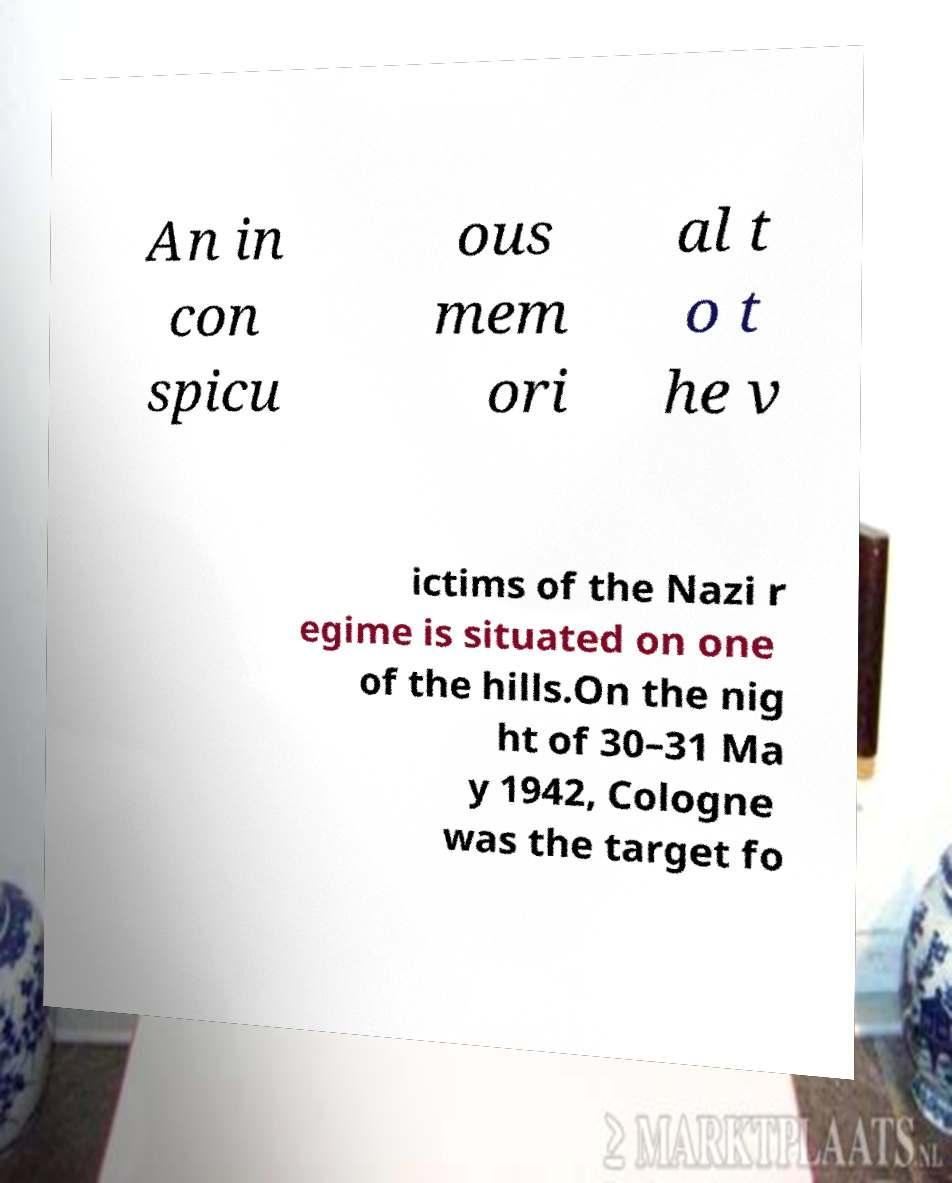Please read and relay the text visible in this image. What does it say? An in con spicu ous mem ori al t o t he v ictims of the Nazi r egime is situated on one of the hills.On the nig ht of 30–31 Ma y 1942, Cologne was the target fo 